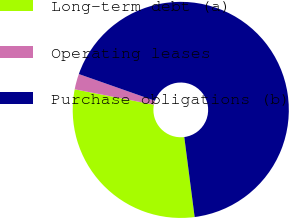<chart> <loc_0><loc_0><loc_500><loc_500><pie_chart><fcel>Long-term debt (a)<fcel>Operating leases<fcel>Purchase obligations (b)<nl><fcel>30.1%<fcel>2.33%<fcel>67.57%<nl></chart> 